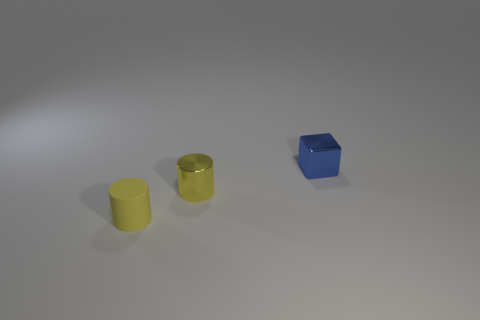Add 1 rubber things. How many objects exist? 4 Subtract all tiny yellow things. Subtract all blue things. How many objects are left? 0 Add 3 small metal cylinders. How many small metal cylinders are left? 4 Add 3 yellow rubber cylinders. How many yellow rubber cylinders exist? 4 Subtract 0 blue balls. How many objects are left? 3 Subtract all blocks. How many objects are left? 2 Subtract all red cylinders. Subtract all gray spheres. How many cylinders are left? 2 